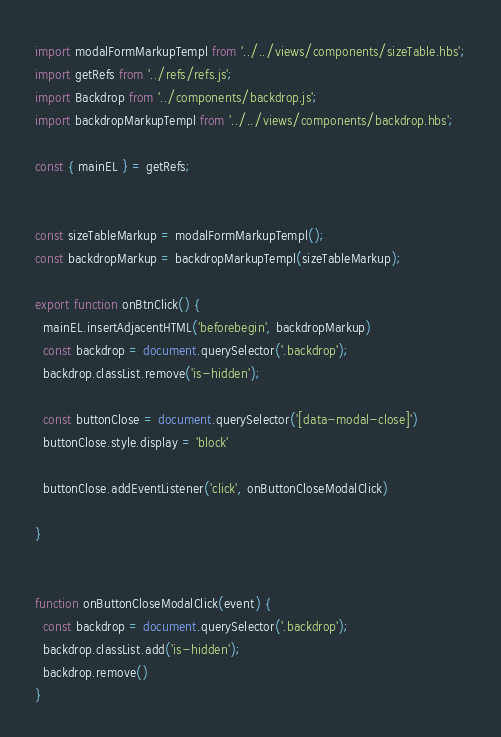<code> <loc_0><loc_0><loc_500><loc_500><_JavaScript_>import modalFormMarkupTempl from '../../views/components/sizeTable.hbs';
import getRefs from '../refs/refs.js';
import Backdrop from '../components/backdrop.js';
import backdropMarkupTempl from '../../views/components/backdrop.hbs';

const { mainEL } = getRefs;


const sizeTableMarkup = modalFormMarkupTempl();
const backdropMarkup = backdropMarkupTempl(sizeTableMarkup);

export function onBtnClick() {
  mainEL.insertAdjacentHTML('beforebegin', backdropMarkup)
  const backdrop = document.querySelector('.backdrop');
  backdrop.classList.remove('is-hidden');
  
  const buttonClose = document.querySelector('[data-modal-close]')
  buttonClose.style.display = 'block'

  buttonClose.addEventListener('click', onButtonCloseModalClick)

}


function onButtonCloseModalClick(event) {
  const backdrop = document.querySelector('.backdrop');
  backdrop.classList.add('is-hidden');
  backdrop.remove()
}
</code> 